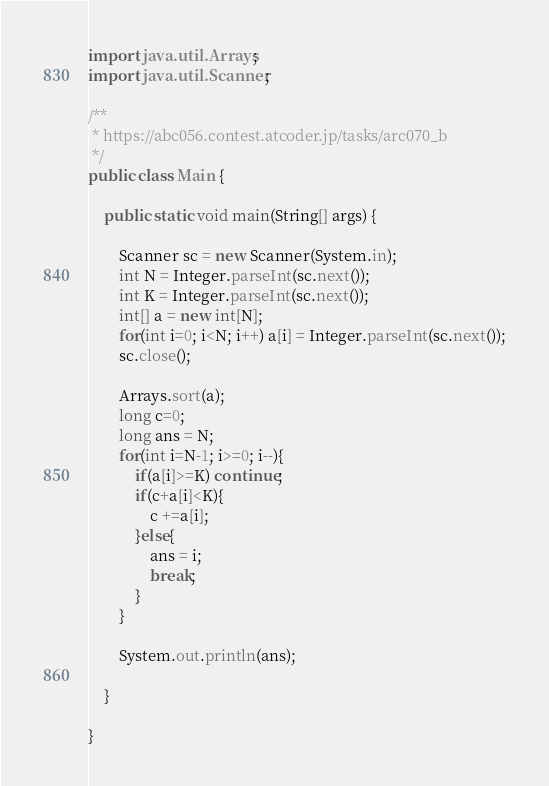Convert code to text. <code><loc_0><loc_0><loc_500><loc_500><_Java_>import java.util.Arrays;
import java.util.Scanner;

/**
 * https://abc056.contest.atcoder.jp/tasks/arc070_b
 */
public class Main {

	public static void main(String[] args) {
		
		Scanner sc = new Scanner(System.in);
		int N = Integer.parseInt(sc.next());
		int K = Integer.parseInt(sc.next());
		int[] a = new int[N];
		for(int i=0; i<N; i++) a[i] = Integer.parseInt(sc.next());
		sc.close();
		
		Arrays.sort(a);
		long c=0;
		long ans = N;
		for(int i=N-1; i>=0; i--){
			if(a[i]>=K) continue;
			if(c+a[i]<K){
				c +=a[i];
			}else{
				ans = i;
				break;
			}
		}
		
		System.out.println(ans);

	}

}</code> 